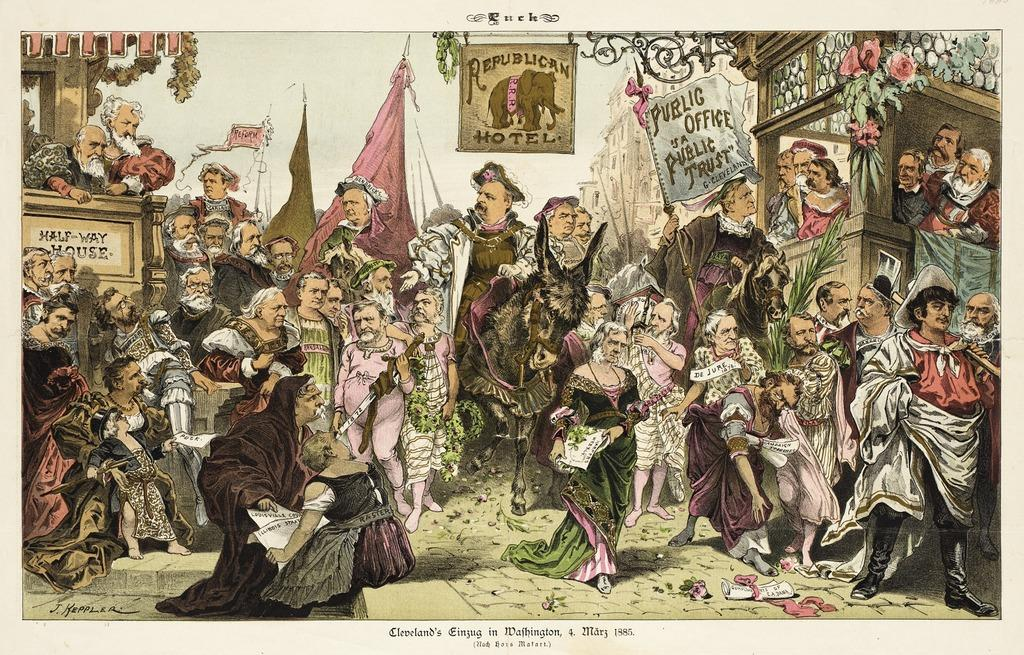<image>
Share a concise interpretation of the image provided. older picture of a bunch of people in a crowd with a sign saying Republican Motel. 